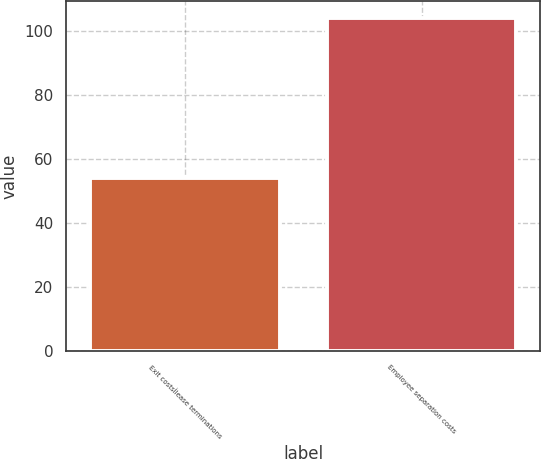Convert chart. <chart><loc_0><loc_0><loc_500><loc_500><bar_chart><fcel>Exit costsÌlease terminations<fcel>Employee separation costs<nl><fcel>54<fcel>104<nl></chart> 